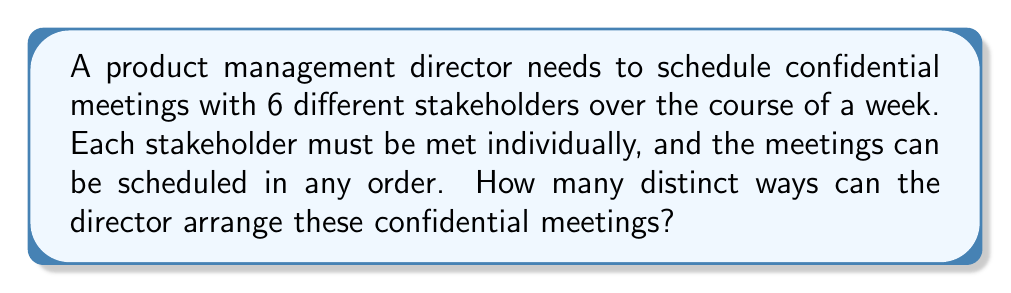What is the answer to this math problem? To solve this problem, we need to use the concept of permutations. Since each stakeholder must be met individually and the order matters (as we're arranging the meetings), this is a perfect scenario for using permutations.

The formula for permutations of n distinct objects is:

$$P(n) = n!$$

Where $n!$ represents the factorial of n.

In this case:
- We have 6 stakeholders (n = 6)
- Each stakeholder must be met (using all 6)
- The order matters (different arrangements are considered distinct)

Therefore, we can directly apply the permutation formula:

$$P(6) = 6!$$

To calculate this:

$$\begin{align}
6! &= 6 \times 5 \times 4 \times 3 \times 2 \times 1 \\
&= 720
\end{align}$$

This means there are 720 distinct ways to arrange these confidential meetings with the 6 stakeholders.
Answer: 720 distinct arrangements 